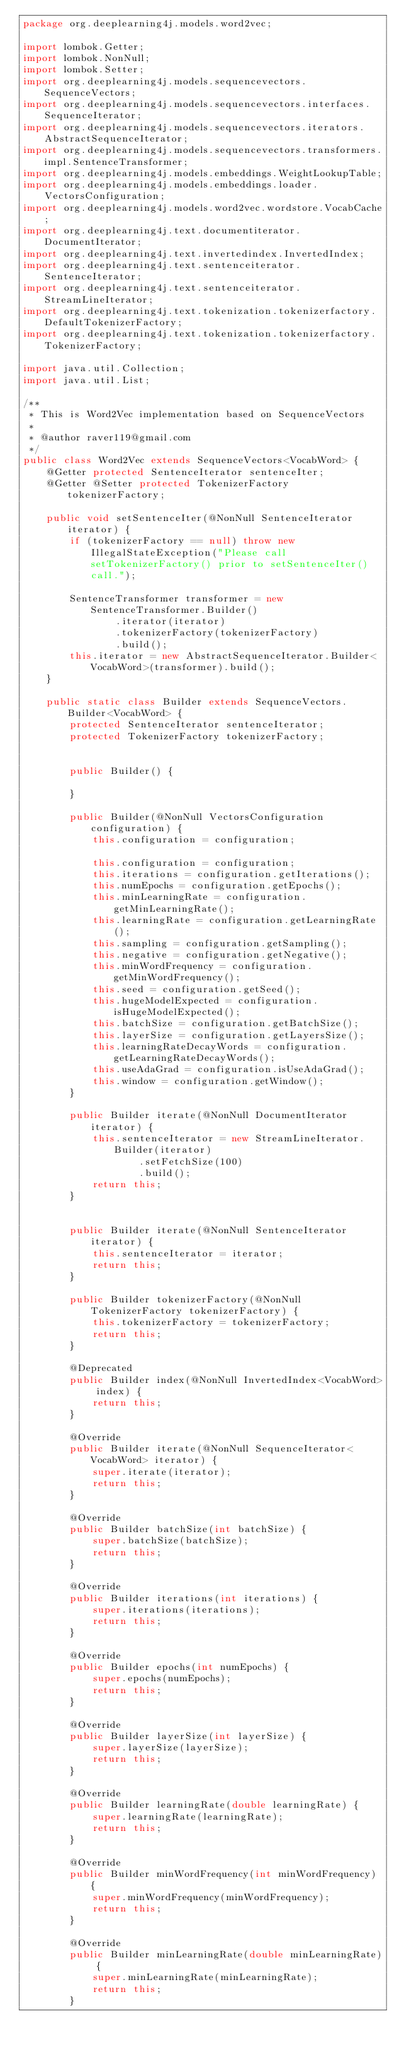<code> <loc_0><loc_0><loc_500><loc_500><_Java_>package org.deeplearning4j.models.word2vec;

import lombok.Getter;
import lombok.NonNull;
import lombok.Setter;
import org.deeplearning4j.models.sequencevectors.SequenceVectors;
import org.deeplearning4j.models.sequencevectors.interfaces.SequenceIterator;
import org.deeplearning4j.models.sequencevectors.iterators.AbstractSequenceIterator;
import org.deeplearning4j.models.sequencevectors.transformers.impl.SentenceTransformer;
import org.deeplearning4j.models.embeddings.WeightLookupTable;
import org.deeplearning4j.models.embeddings.loader.VectorsConfiguration;
import org.deeplearning4j.models.word2vec.wordstore.VocabCache;
import org.deeplearning4j.text.documentiterator.DocumentIterator;
import org.deeplearning4j.text.invertedindex.InvertedIndex;
import org.deeplearning4j.text.sentenceiterator.SentenceIterator;
import org.deeplearning4j.text.sentenceiterator.StreamLineIterator;
import org.deeplearning4j.text.tokenization.tokenizerfactory.DefaultTokenizerFactory;
import org.deeplearning4j.text.tokenization.tokenizerfactory.TokenizerFactory;

import java.util.Collection;
import java.util.List;

/**
 * This is Word2Vec implementation based on SequenceVectors
 *
 * @author raver119@gmail.com
 */
public class Word2Vec extends SequenceVectors<VocabWord> {
    @Getter protected SentenceIterator sentenceIter;
    @Getter @Setter protected TokenizerFactory tokenizerFactory;

    public void setSentenceIter(@NonNull SentenceIterator iterator) {
        if (tokenizerFactory == null) throw new IllegalStateException("Please call setTokenizerFactory() prior to setSentenceIter() call.");

        SentenceTransformer transformer = new SentenceTransformer.Builder()
                .iterator(iterator)
                .tokenizerFactory(tokenizerFactory)
                .build();
        this.iterator = new AbstractSequenceIterator.Builder<VocabWord>(transformer).build();
    }

    public static class Builder extends SequenceVectors.Builder<VocabWord> {
        protected SentenceIterator sentenceIterator;
        protected TokenizerFactory tokenizerFactory;


        public Builder() {

        }

        public Builder(@NonNull VectorsConfiguration configuration) {
            this.configuration = configuration;

            this.configuration = configuration;
            this.iterations = configuration.getIterations();
            this.numEpochs = configuration.getEpochs();
            this.minLearningRate = configuration.getMinLearningRate();
            this.learningRate = configuration.getLearningRate();
            this.sampling = configuration.getSampling();
            this.negative = configuration.getNegative();
            this.minWordFrequency = configuration.getMinWordFrequency();
            this.seed = configuration.getSeed();
            this.hugeModelExpected = configuration.isHugeModelExpected();
            this.batchSize = configuration.getBatchSize();
            this.layerSize = configuration.getLayersSize();
            this.learningRateDecayWords = configuration.getLearningRateDecayWords();
            this.useAdaGrad = configuration.isUseAdaGrad();
            this.window = configuration.getWindow();
        }

        public Builder iterate(@NonNull DocumentIterator iterator) {
            this.sentenceIterator = new StreamLineIterator.Builder(iterator)
                    .setFetchSize(100)
                    .build();
            return this;
        }


        public Builder iterate(@NonNull SentenceIterator iterator) {
            this.sentenceIterator = iterator;
            return this;
        }

        public Builder tokenizerFactory(@NonNull TokenizerFactory tokenizerFactory) {
            this.tokenizerFactory = tokenizerFactory;
            return this;
        }

        @Deprecated
        public Builder index(@NonNull InvertedIndex<VocabWord> index) {
            return this;
        }

        @Override
        public Builder iterate(@NonNull SequenceIterator<VocabWord> iterator) {
            super.iterate(iterator);
            return this;
        }

        @Override
        public Builder batchSize(int batchSize) {
            super.batchSize(batchSize);
            return this;
        }

        @Override
        public Builder iterations(int iterations) {
            super.iterations(iterations);
            return this;
        }

        @Override
        public Builder epochs(int numEpochs) {
            super.epochs(numEpochs);
            return this;
        }

        @Override
        public Builder layerSize(int layerSize) {
            super.layerSize(layerSize);
            return this;
        }

        @Override
        public Builder learningRate(double learningRate) {
            super.learningRate(learningRate);
            return this;
        }

        @Override
        public Builder minWordFrequency(int minWordFrequency) {
            super.minWordFrequency(minWordFrequency);
            return this;
        }

        @Override
        public Builder minLearningRate(double minLearningRate) {
            super.minLearningRate(minLearningRate);
            return this;
        }
</code> 